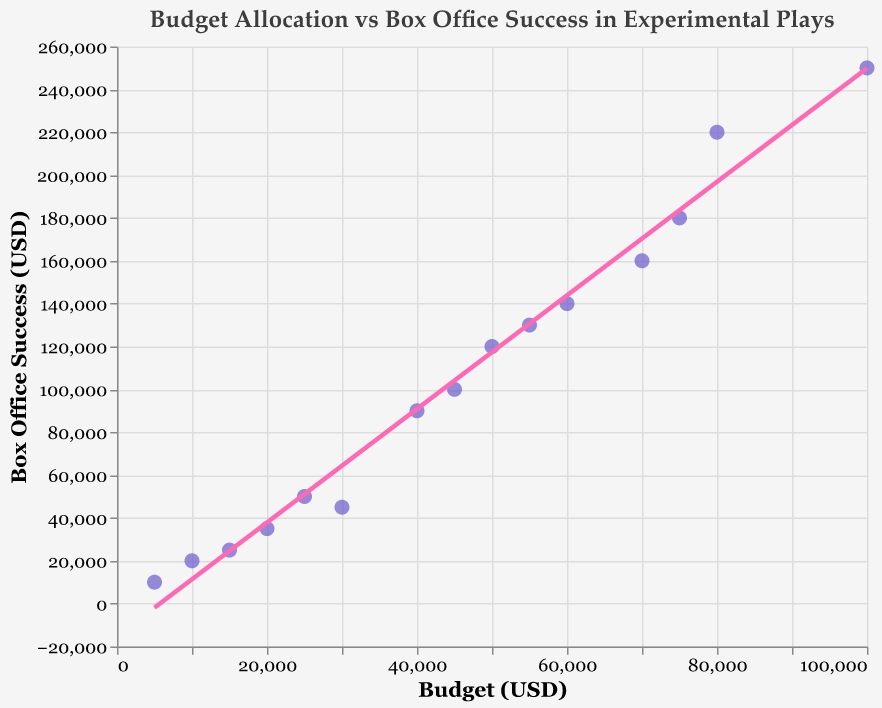How many data points (plays) are included in the scatter plot? Count the individual points (plays) on the scatter plot.
Answer: 15 What is the title of the plot? Look at the top of the plot to identify the title.
Answer: Budget Allocation vs Box Office Success in Experimental Plays Which play has the highest box office success? Find the point that is highest on the y-axis. The tooltip or the data labels can help identify the play.
Answer: The Infinite Dialogues How does the budget allocation generally relate to box office success according to the trend line? Observe the general direction of the trend line. If it is upward, there is a positive relationship; if downward, a negative relationship.
Answer: Positive relationship What is the box office success for the play with the smallest budget? Locate the point with the smallest x-axis value (budget) and check its y-axis value (box office success).
Answer: 10,000 USD What is the approximate slope of the trend line? Identify the general rise over run (change in y divided by change in x). A positive slope indicates a general incline of the trend line.
Answer: Positive slope Which play has a budget closest to 50,000 USD? Identify the point nearest to 50,000 USD on the x-axis and view the corresponding tooltip for the play's name.
Answer: The Avant-Garde Symphony By how much does the highest box office success exceed the lowest box office success? Identify the highest and lowest y-values and calculate the difference between them.
Answer: 250,000 USD - 10,000 USD = 240,000 USD Compare the box office success of "Quantum Realities" and "Being and Nothingness". Which one is higher and by how much? Locate the points corresponding to these titles and compare their y-values. Subtract the smaller y-value from the larger one.
Answer: Quantum Realities by 20,000 USD Among the plays with a budget between 20,000 USD to 30,000 USD, which one has the highest box office success? Find points within the x-axis range of 20,000 USD to 30,000 USD and compare their y-values to determine the highest.
Answer: Temporal Loop 